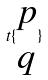Convert formula to latex. <formula><loc_0><loc_0><loc_500><loc_500>t \{ \begin{matrix} p \\ q \end{matrix} \}</formula> 